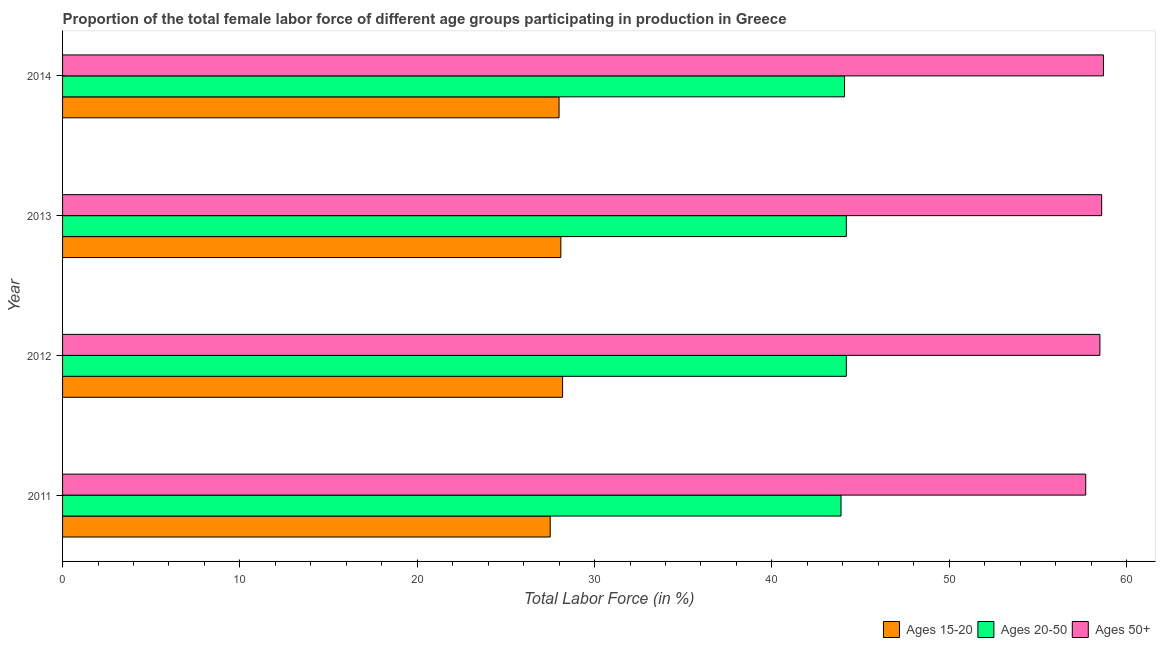Are the number of bars on each tick of the Y-axis equal?
Ensure brevity in your answer.  Yes. How many bars are there on the 1st tick from the bottom?
Provide a short and direct response. 3. In how many cases, is the number of bars for a given year not equal to the number of legend labels?
Give a very brief answer. 0. What is the percentage of female labor force above age 50 in 2012?
Provide a short and direct response. 58.5. Across all years, what is the maximum percentage of female labor force within the age group 15-20?
Ensure brevity in your answer.  28.2. Across all years, what is the minimum percentage of female labor force within the age group 20-50?
Make the answer very short. 43.9. What is the total percentage of female labor force within the age group 20-50 in the graph?
Offer a very short reply. 176.4. What is the average percentage of female labor force within the age group 15-20 per year?
Offer a terse response. 27.95. In the year 2012, what is the difference between the percentage of female labor force above age 50 and percentage of female labor force within the age group 15-20?
Offer a terse response. 30.3. In how many years, is the percentage of female labor force above age 50 greater than 2 %?
Provide a succinct answer. 4. What is the difference between the highest and the second highest percentage of female labor force above age 50?
Provide a succinct answer. 0.1. What does the 1st bar from the top in 2012 represents?
Your answer should be very brief. Ages 50+. What does the 1st bar from the bottom in 2011 represents?
Provide a succinct answer. Ages 15-20. Is it the case that in every year, the sum of the percentage of female labor force within the age group 15-20 and percentage of female labor force within the age group 20-50 is greater than the percentage of female labor force above age 50?
Your answer should be compact. Yes. How many bars are there?
Your response must be concise. 12. How many years are there in the graph?
Offer a terse response. 4. What is the difference between two consecutive major ticks on the X-axis?
Your response must be concise. 10. Are the values on the major ticks of X-axis written in scientific E-notation?
Ensure brevity in your answer.  No. How many legend labels are there?
Offer a terse response. 3. What is the title of the graph?
Your answer should be very brief. Proportion of the total female labor force of different age groups participating in production in Greece. What is the label or title of the X-axis?
Provide a short and direct response. Total Labor Force (in %). What is the Total Labor Force (in %) in Ages 15-20 in 2011?
Provide a succinct answer. 27.5. What is the Total Labor Force (in %) of Ages 20-50 in 2011?
Provide a succinct answer. 43.9. What is the Total Labor Force (in %) of Ages 50+ in 2011?
Provide a succinct answer. 57.7. What is the Total Labor Force (in %) of Ages 15-20 in 2012?
Ensure brevity in your answer.  28.2. What is the Total Labor Force (in %) in Ages 20-50 in 2012?
Keep it short and to the point. 44.2. What is the Total Labor Force (in %) of Ages 50+ in 2012?
Offer a very short reply. 58.5. What is the Total Labor Force (in %) of Ages 15-20 in 2013?
Provide a succinct answer. 28.1. What is the Total Labor Force (in %) in Ages 20-50 in 2013?
Offer a very short reply. 44.2. What is the Total Labor Force (in %) of Ages 50+ in 2013?
Your answer should be very brief. 58.6. What is the Total Labor Force (in %) of Ages 15-20 in 2014?
Offer a terse response. 28. What is the Total Labor Force (in %) in Ages 20-50 in 2014?
Provide a succinct answer. 44.1. What is the Total Labor Force (in %) in Ages 50+ in 2014?
Your answer should be very brief. 58.7. Across all years, what is the maximum Total Labor Force (in %) in Ages 15-20?
Ensure brevity in your answer.  28.2. Across all years, what is the maximum Total Labor Force (in %) of Ages 20-50?
Give a very brief answer. 44.2. Across all years, what is the maximum Total Labor Force (in %) of Ages 50+?
Give a very brief answer. 58.7. Across all years, what is the minimum Total Labor Force (in %) in Ages 15-20?
Keep it short and to the point. 27.5. Across all years, what is the minimum Total Labor Force (in %) in Ages 20-50?
Ensure brevity in your answer.  43.9. Across all years, what is the minimum Total Labor Force (in %) of Ages 50+?
Keep it short and to the point. 57.7. What is the total Total Labor Force (in %) of Ages 15-20 in the graph?
Give a very brief answer. 111.8. What is the total Total Labor Force (in %) in Ages 20-50 in the graph?
Keep it short and to the point. 176.4. What is the total Total Labor Force (in %) in Ages 50+ in the graph?
Offer a very short reply. 233.5. What is the difference between the Total Labor Force (in %) of Ages 15-20 in 2011 and that in 2012?
Provide a short and direct response. -0.7. What is the difference between the Total Labor Force (in %) of Ages 20-50 in 2011 and that in 2013?
Ensure brevity in your answer.  -0.3. What is the difference between the Total Labor Force (in %) in Ages 20-50 in 2011 and that in 2014?
Provide a short and direct response. -0.2. What is the difference between the Total Labor Force (in %) of Ages 20-50 in 2012 and that in 2013?
Make the answer very short. 0. What is the difference between the Total Labor Force (in %) in Ages 15-20 in 2012 and that in 2014?
Offer a terse response. 0.2. What is the difference between the Total Labor Force (in %) in Ages 20-50 in 2012 and that in 2014?
Your response must be concise. 0.1. What is the difference between the Total Labor Force (in %) of Ages 50+ in 2012 and that in 2014?
Give a very brief answer. -0.2. What is the difference between the Total Labor Force (in %) in Ages 50+ in 2013 and that in 2014?
Ensure brevity in your answer.  -0.1. What is the difference between the Total Labor Force (in %) in Ages 15-20 in 2011 and the Total Labor Force (in %) in Ages 20-50 in 2012?
Your answer should be compact. -16.7. What is the difference between the Total Labor Force (in %) of Ages 15-20 in 2011 and the Total Labor Force (in %) of Ages 50+ in 2012?
Provide a short and direct response. -31. What is the difference between the Total Labor Force (in %) of Ages 20-50 in 2011 and the Total Labor Force (in %) of Ages 50+ in 2012?
Your response must be concise. -14.6. What is the difference between the Total Labor Force (in %) of Ages 15-20 in 2011 and the Total Labor Force (in %) of Ages 20-50 in 2013?
Keep it short and to the point. -16.7. What is the difference between the Total Labor Force (in %) in Ages 15-20 in 2011 and the Total Labor Force (in %) in Ages 50+ in 2013?
Keep it short and to the point. -31.1. What is the difference between the Total Labor Force (in %) in Ages 20-50 in 2011 and the Total Labor Force (in %) in Ages 50+ in 2013?
Offer a very short reply. -14.7. What is the difference between the Total Labor Force (in %) in Ages 15-20 in 2011 and the Total Labor Force (in %) in Ages 20-50 in 2014?
Provide a succinct answer. -16.6. What is the difference between the Total Labor Force (in %) of Ages 15-20 in 2011 and the Total Labor Force (in %) of Ages 50+ in 2014?
Your response must be concise. -31.2. What is the difference between the Total Labor Force (in %) in Ages 20-50 in 2011 and the Total Labor Force (in %) in Ages 50+ in 2014?
Provide a short and direct response. -14.8. What is the difference between the Total Labor Force (in %) of Ages 15-20 in 2012 and the Total Labor Force (in %) of Ages 20-50 in 2013?
Offer a very short reply. -16. What is the difference between the Total Labor Force (in %) in Ages 15-20 in 2012 and the Total Labor Force (in %) in Ages 50+ in 2013?
Give a very brief answer. -30.4. What is the difference between the Total Labor Force (in %) in Ages 20-50 in 2012 and the Total Labor Force (in %) in Ages 50+ in 2013?
Give a very brief answer. -14.4. What is the difference between the Total Labor Force (in %) in Ages 15-20 in 2012 and the Total Labor Force (in %) in Ages 20-50 in 2014?
Give a very brief answer. -15.9. What is the difference between the Total Labor Force (in %) of Ages 15-20 in 2012 and the Total Labor Force (in %) of Ages 50+ in 2014?
Your answer should be very brief. -30.5. What is the difference between the Total Labor Force (in %) in Ages 15-20 in 2013 and the Total Labor Force (in %) in Ages 50+ in 2014?
Offer a very short reply. -30.6. What is the average Total Labor Force (in %) in Ages 15-20 per year?
Ensure brevity in your answer.  27.95. What is the average Total Labor Force (in %) in Ages 20-50 per year?
Ensure brevity in your answer.  44.1. What is the average Total Labor Force (in %) in Ages 50+ per year?
Give a very brief answer. 58.38. In the year 2011, what is the difference between the Total Labor Force (in %) of Ages 15-20 and Total Labor Force (in %) of Ages 20-50?
Your response must be concise. -16.4. In the year 2011, what is the difference between the Total Labor Force (in %) in Ages 15-20 and Total Labor Force (in %) in Ages 50+?
Provide a short and direct response. -30.2. In the year 2012, what is the difference between the Total Labor Force (in %) in Ages 15-20 and Total Labor Force (in %) in Ages 50+?
Offer a very short reply. -30.3. In the year 2012, what is the difference between the Total Labor Force (in %) in Ages 20-50 and Total Labor Force (in %) in Ages 50+?
Provide a succinct answer. -14.3. In the year 2013, what is the difference between the Total Labor Force (in %) of Ages 15-20 and Total Labor Force (in %) of Ages 20-50?
Your answer should be very brief. -16.1. In the year 2013, what is the difference between the Total Labor Force (in %) in Ages 15-20 and Total Labor Force (in %) in Ages 50+?
Offer a very short reply. -30.5. In the year 2013, what is the difference between the Total Labor Force (in %) in Ages 20-50 and Total Labor Force (in %) in Ages 50+?
Make the answer very short. -14.4. In the year 2014, what is the difference between the Total Labor Force (in %) of Ages 15-20 and Total Labor Force (in %) of Ages 20-50?
Ensure brevity in your answer.  -16.1. In the year 2014, what is the difference between the Total Labor Force (in %) in Ages 15-20 and Total Labor Force (in %) in Ages 50+?
Your answer should be compact. -30.7. In the year 2014, what is the difference between the Total Labor Force (in %) of Ages 20-50 and Total Labor Force (in %) of Ages 50+?
Offer a terse response. -14.6. What is the ratio of the Total Labor Force (in %) of Ages 15-20 in 2011 to that in 2012?
Make the answer very short. 0.98. What is the ratio of the Total Labor Force (in %) in Ages 50+ in 2011 to that in 2012?
Give a very brief answer. 0.99. What is the ratio of the Total Labor Force (in %) in Ages 15-20 in 2011 to that in 2013?
Your response must be concise. 0.98. What is the ratio of the Total Labor Force (in %) of Ages 50+ in 2011 to that in 2013?
Offer a terse response. 0.98. What is the ratio of the Total Labor Force (in %) in Ages 15-20 in 2011 to that in 2014?
Offer a very short reply. 0.98. What is the ratio of the Total Labor Force (in %) of Ages 15-20 in 2012 to that in 2013?
Your answer should be very brief. 1. What is the ratio of the Total Labor Force (in %) of Ages 20-50 in 2012 to that in 2013?
Make the answer very short. 1. What is the ratio of the Total Labor Force (in %) of Ages 15-20 in 2012 to that in 2014?
Your response must be concise. 1.01. What is the ratio of the Total Labor Force (in %) in Ages 50+ in 2012 to that in 2014?
Ensure brevity in your answer.  1. What is the ratio of the Total Labor Force (in %) of Ages 50+ in 2013 to that in 2014?
Provide a short and direct response. 1. What is the difference between the highest and the second highest Total Labor Force (in %) of Ages 15-20?
Your answer should be compact. 0.1. What is the difference between the highest and the second highest Total Labor Force (in %) of Ages 20-50?
Keep it short and to the point. 0. What is the difference between the highest and the lowest Total Labor Force (in %) of Ages 50+?
Give a very brief answer. 1. 